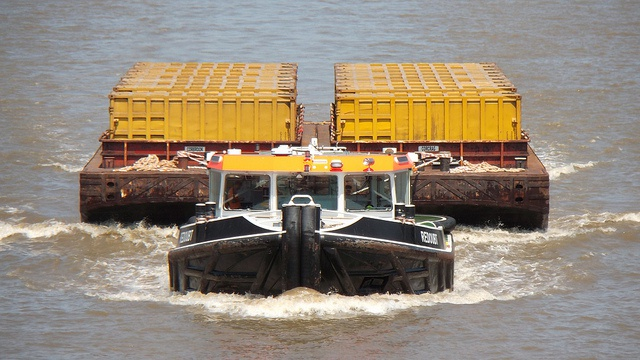Describe the objects in this image and their specific colors. I can see a boat in gray, black, white, and darkgray tones in this image. 